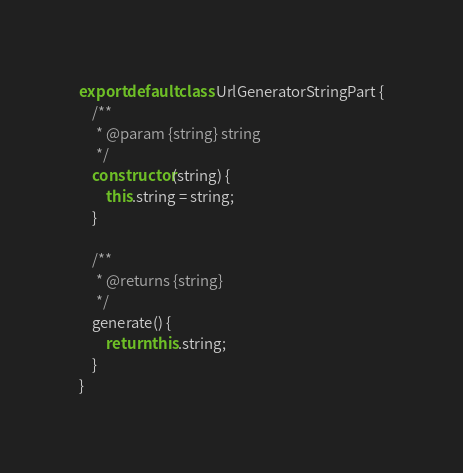<code> <loc_0><loc_0><loc_500><loc_500><_JavaScript_>export default class UrlGeneratorStringPart {
    /**
     * @param {string} string
     */
    constructor(string) {
        this.string = string;
    }

    /**
     * @returns {string}
     */
    generate() {
        return this.string;
    }
}
</code> 